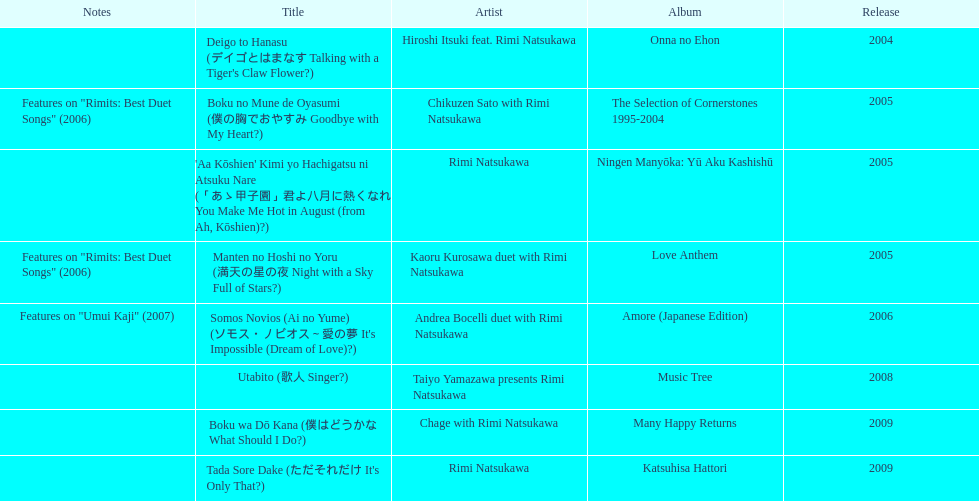What has been the last song this artist has made an other appearance on? Tada Sore Dake. 